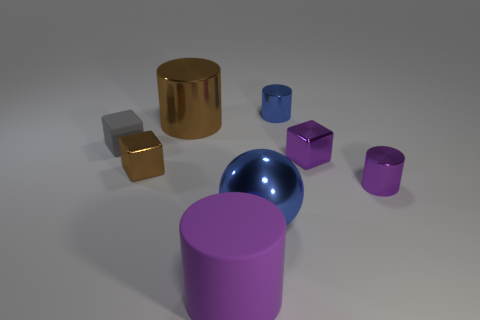Is there anything else that is the same color as the small rubber cube? After careful observation of the image, it appears that there are no other objects sharing the exact hue of the small rubber cube. However, there are different objects in a variety of shades and finishes that create a visually diverse scene. 